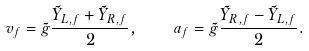<formula> <loc_0><loc_0><loc_500><loc_500>v _ { f } = \tilde { g } \frac { \tilde { Y } _ { L , f } + \tilde { Y } _ { R , f } } { 2 } , \quad a _ { f } = \tilde { g } \frac { \tilde { Y } _ { R , f } - \tilde { Y } _ { L , f } } { 2 } .</formula> 